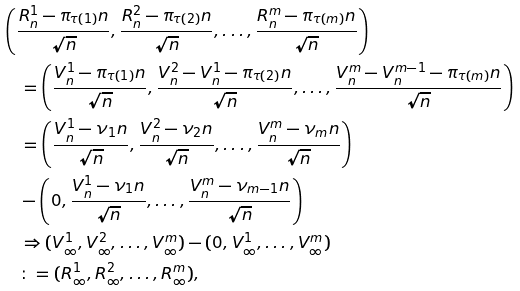Convert formula to latex. <formula><loc_0><loc_0><loc_500><loc_500>& \left ( \frac { R _ { n } ^ { 1 } - \pi _ { \tau ( 1 ) } n } { \sqrt { n } } , \frac { R _ { n } ^ { 2 } - \pi _ { \tau ( 2 ) } n } { \sqrt { n } } , \dots , \frac { R _ { n } ^ { m } - \pi _ { \tau ( m ) } n } { \sqrt { n } } \right ) \\ & \quad = \left ( \frac { V _ { n } ^ { 1 } - \pi _ { \tau ( 1 ) } n } { \sqrt { n } } , \frac { V _ { n } ^ { 2 } - V _ { n } ^ { 1 } - \pi _ { \tau ( 2 ) } n } { \sqrt { n } } , \dots , \frac { V _ { n } ^ { m } - V _ { n } ^ { m - 1 } - \pi _ { \tau ( m ) } n } { \sqrt { n } } \right ) \\ & \quad = \left ( \frac { V _ { n } ^ { 1 } - \nu _ { 1 } n } { \sqrt { n } } , \frac { V _ { n } ^ { 2 } - \nu _ { 2 } n } { \sqrt { n } } , \dots , \frac { V _ { n } ^ { m } - \nu _ { m } n } { \sqrt { n } } \right ) \\ & \quad - \left ( 0 , \frac { V _ { n } ^ { 1 } - \nu _ { 1 } n } { \sqrt { n } } , \dots , \frac { V _ { n } ^ { m } - \nu _ { m - 1 } n } { \sqrt { n } } \right ) \\ & \quad \Rightarrow ( V _ { \infty } ^ { 1 } , V _ { \infty } ^ { 2 } , \dots , V _ { \infty } ^ { m } ) - ( 0 , V _ { \infty } ^ { 1 } , \dots , V _ { \infty } ^ { m } ) \\ & \quad \colon = ( R _ { \infty } ^ { 1 } , R _ { \infty } ^ { 2 } , \dots , R _ { \infty } ^ { m } ) ,</formula> 